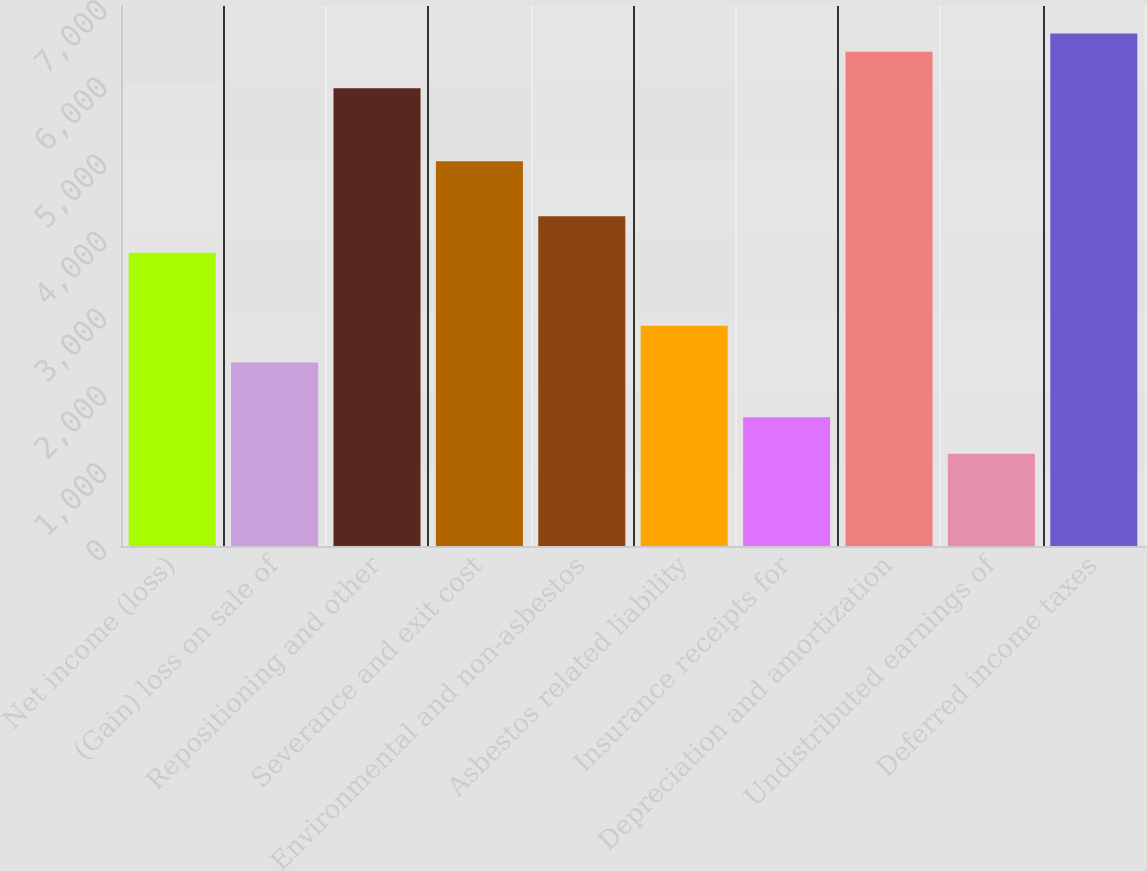Convert chart to OTSL. <chart><loc_0><loc_0><loc_500><loc_500><bar_chart><fcel>Net income (loss)<fcel>(Gain) loss on sale of<fcel>Repositioning and other<fcel>Severance and exit cost<fcel>Environmental and non-asbestos<fcel>Asbestos related liability<fcel>Insurance receipts for<fcel>Depreciation and amortization<fcel>Undistributed earnings of<fcel>Deferred income taxes<nl><fcel>3801.4<fcel>2380<fcel>5933.5<fcel>4985.9<fcel>4275.2<fcel>2853.8<fcel>1669.3<fcel>6407.3<fcel>1195.5<fcel>6644.2<nl></chart> 